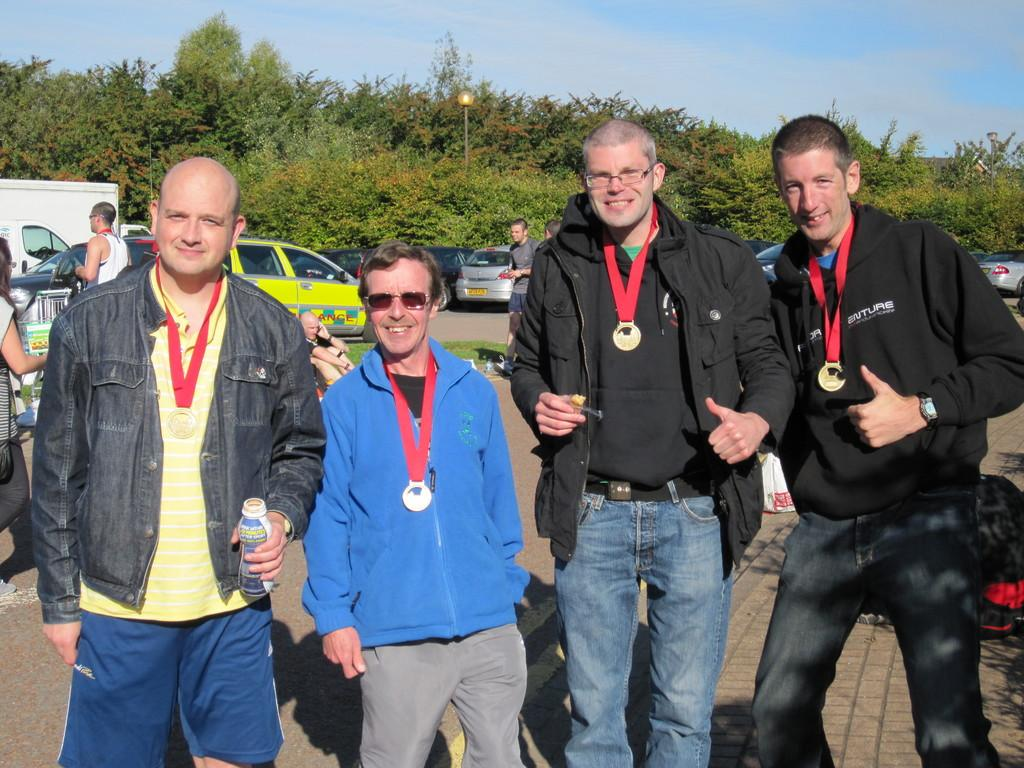How many people are in the image? There are four men in the image. What are the men doing in the image? The men are standing and smiling. What are the men wearing in the image? The men are wearing medals. What can be seen in the background of the image? There are vehicles and trees in the background of the image. What is visible at the top of the image? The sky is visible at the top of the image. What type of cake is being served to the men in the image? There is no cake present in the image; the men are wearing medals. Can you describe the lipstick color of the man on the left in the image? There is no lipstick or indication of gender in the image, as the men are wearing medals and smiling. 